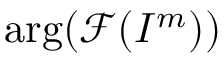Convert formula to latex. <formula><loc_0><loc_0><loc_500><loc_500>\arg ( \mathcal { F } ( I ^ { m } ) )</formula> 